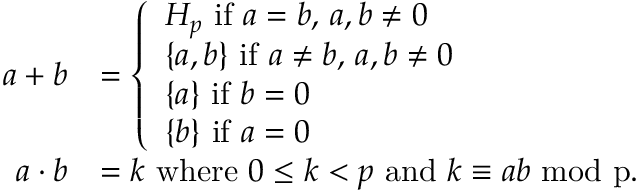Convert formula to latex. <formula><loc_0><loc_0><loc_500><loc_500>\begin{array} { r l } { a + b } & { = \left \{ \begin{array} { l l } { H _ { p } i f a = b , \, a , b \ne 0 } \\ { \{ a , b \} i f a \ne b , \, a , b \ne 0 } \\ { \{ a \} i f b = 0 } \\ { \{ b \} i f a = 0 } \end{array} } \\ { a \cdot b } & { = k w h e r e 0 \leq k < p a n d k \equiv a b m o d p . } \end{array}</formula> 